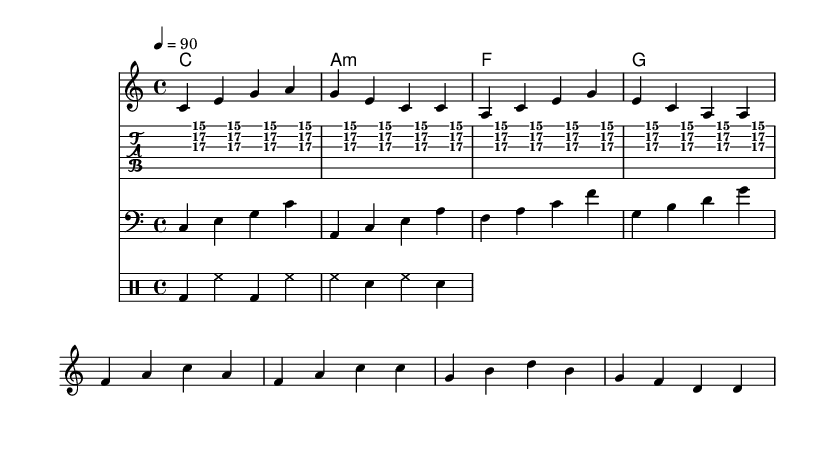What is the key signature of this music? The key signature is indicated to be C major, which is characterized by having no sharps or flats.
Answer: C major What is the time signature of this piece? The time signature is noted at the beginning of the score and is written as 4/4, meaning there are four beats in each measure.
Answer: 4/4 What is the tempo marking of the music? The tempo marking indicates that the piece should be played at a speed of 90 beats per minute, as it’s indicated by "4 = 90".
Answer: 90 Which chord is played in the first measure? The first measure contains a C major chord, as denoted by the corresponding chord name under the staff.
Answer: C How many times is the guitar skank pattern repeated? The guitar skank pattern is indicated to be repeated 4 times, as shown by the phrasing "repeat unfold 4" in the code.
Answer: 4 What is the lyrical theme of this piece? The lyrics reflect themes of international collaboration and cultural exchange, as words like "bridges," "collaborating," and "global" convey this message clearly.
Answer: International collaboration What instrument is likely to play the bass line? The clef used in the score is a bass clef, which indicates that this line is typically played by a bass instrument, such as a bass guitar.
Answer: Bass 